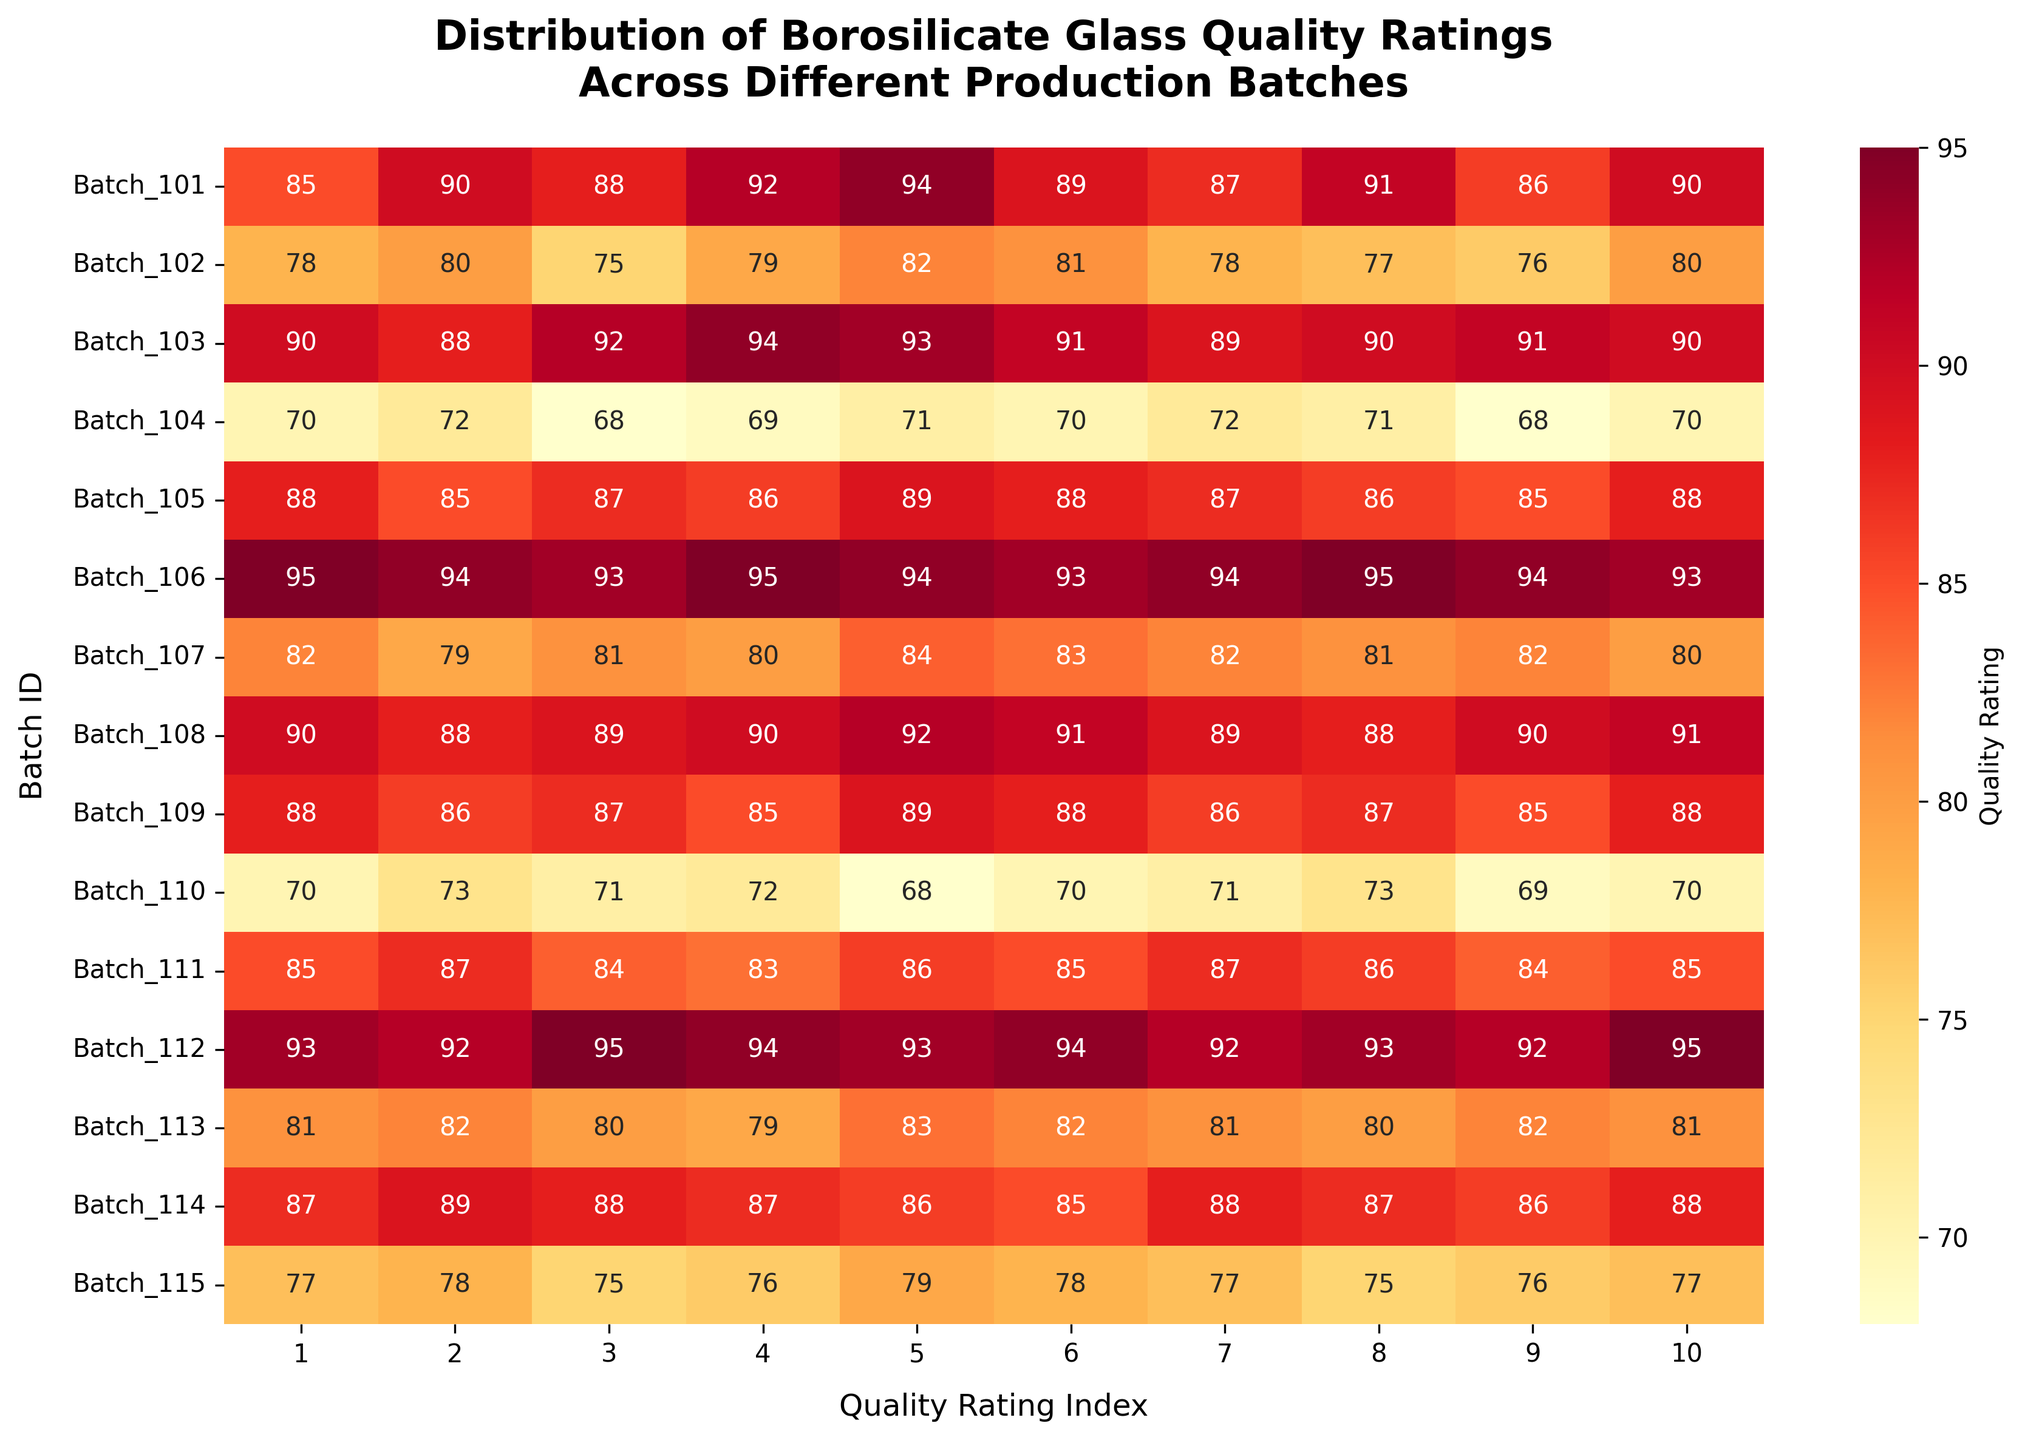What's the title of the heatmap? Look at the text positioned at the top center of the figure. It describes the overall content of the heatmap.
Answer: Distribution of Borosilicate Glass Quality Ratings Across Different Production Batches How many quality ratings are evaluated for each batch? Count the number of columns in the heatmap excluding the axis labels. Each column represents a quality rating index.
Answer: 10 Which batch has the highest average quality rating? Calculate the average quality rating for each batch and then compare them. Batch 106 has consistently high ratings across all indices.
Answer: Batch 106 What is the lowest quality rating for Batch 102? Find Batch 102 in the y-axis, then locate the minimum value in its corresponding row in the heatmap.
Answer: 75 How does the quality rating of Batch 110 at Quality Rating Index 4 compare to Batch 113 at the same index? Locate Quality Rating Index 4 on the x-axis and compare the values for Batch 110 and Batch 113. Batch 110 has a rating of 72 and Batch 113 has a rating of 79.
Answer: Batch 113 has a higher rating What's the average quality rating for Batch 104? Sum all the quality ratings for Batch 104 and divide by the number of ratings (10) to find the average. (70 + 72 + 68 + 69 + 71 + 70 + 72 + 71 + 68 + 70) / 10 = 70.1
Answer: 70.1 Which batch shows the most consistent quality ratings (i.e., the least variation)? Examine each row to find the batch where the ratings are most similar. Batch 106 has very similar ratings, indicating consistency.
Answer: Batch 106 Does any batch have a quality rating of 95? If so, which batch(es)? Scan through the heatmap for any cells annotated with 95. Batches 106 and 112 have a quality rating of 95.
Answer: Batches 106 and 112 Compare the quality ratings of Batch 111 and Batch 114. Which one generally has higher ratings? Compare the values in the rows corresponding to Batch 111 and Batch 114. Both have very similar ratings, but Batch 114 generally has slightly higher values.
Answer: Batch 114 How does the color intensity correlate with the quality ratings on the heatmap? Observe that the heatmap uses a color gradient from light yellow to dark red. Higher quality ratings are indicated by darker red hues, and lower ratings by lighter yellows.
Answer: Darker red indicates higher ratings 